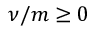Convert formula to latex. <formula><loc_0><loc_0><loc_500><loc_500>\nu / m \geq 0</formula> 